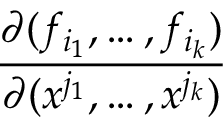Convert formula to latex. <formula><loc_0><loc_0><loc_500><loc_500>\frac { \partial ( f _ { i _ { 1 } } , \dots , f _ { i _ { k } } ) } { \partial ( x ^ { j _ { 1 } } , \dots , x ^ { j _ { k } } ) }</formula> 